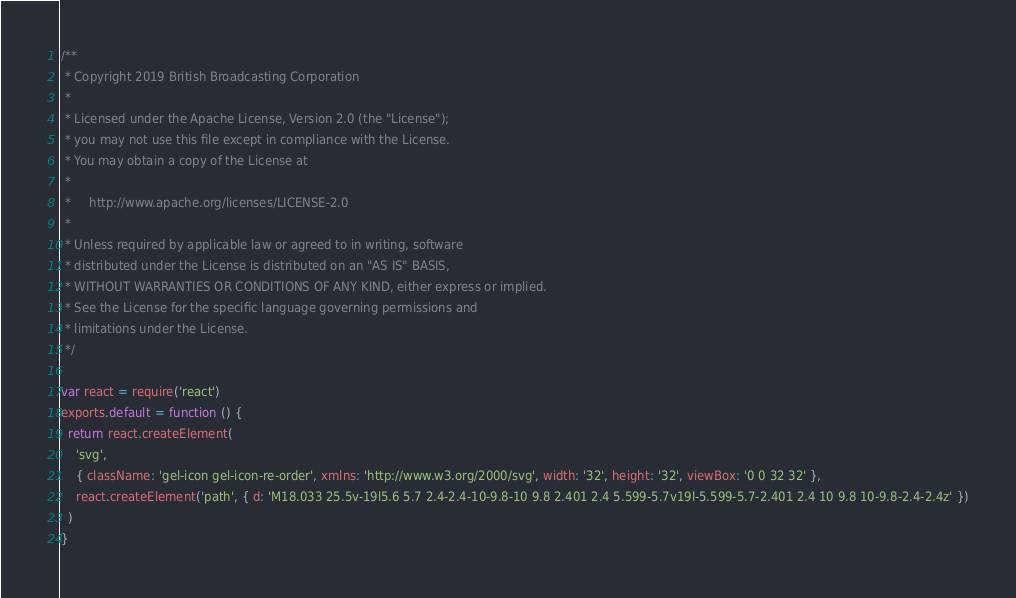<code> <loc_0><loc_0><loc_500><loc_500><_JavaScript_>/**
 * Copyright 2019 British Broadcasting Corporation
 *
 * Licensed under the Apache License, Version 2.0 (the "License");
 * you may not use this file except in compliance with the License.
 * You may obtain a copy of the License at
 *
 *     http://www.apache.org/licenses/LICENSE-2.0
 *
 * Unless required by applicable law or agreed to in writing, software
 * distributed under the License is distributed on an "AS IS" BASIS,
 * WITHOUT WARRANTIES OR CONDITIONS OF ANY KIND, either express or implied.
 * See the License for the specific language governing permissions and
 * limitations under the License.
 */

var react = require('react')
exports.default = function () {
  return react.createElement(
    'svg',
    { className: 'gel-icon gel-icon-re-order', xmlns: 'http://www.w3.org/2000/svg', width: '32', height: '32', viewBox: '0 0 32 32' },
    react.createElement('path', { d: 'M18.033 25.5v-19l5.6 5.7 2.4-2.4-10-9.8-10 9.8 2.401 2.4 5.599-5.7v19l-5.599-5.7-2.401 2.4 10 9.8 10-9.8-2.4-2.4z' })
  )
}
</code> 